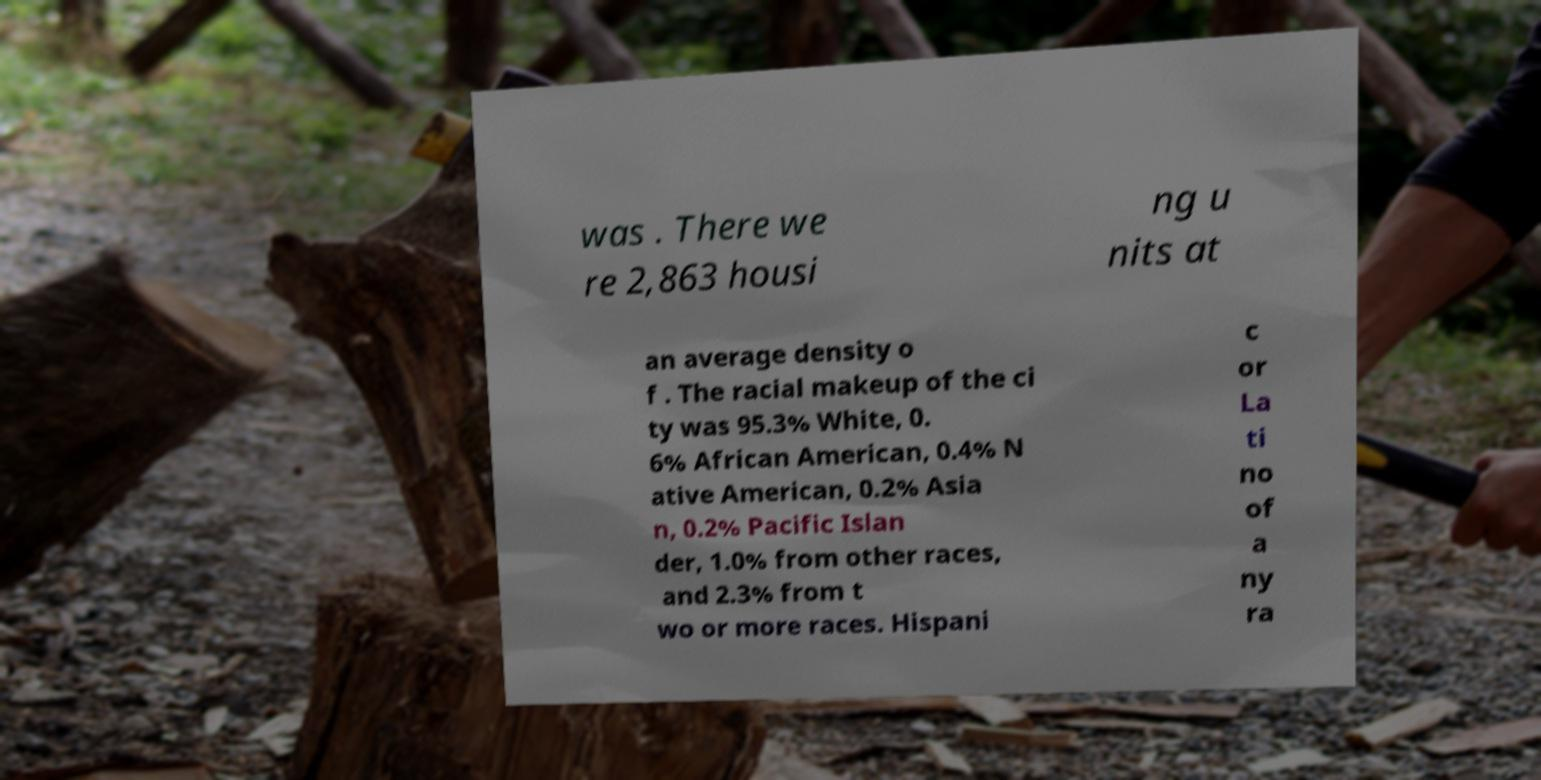Can you read and provide the text displayed in the image?This photo seems to have some interesting text. Can you extract and type it out for me? was . There we re 2,863 housi ng u nits at an average density o f . The racial makeup of the ci ty was 95.3% White, 0. 6% African American, 0.4% N ative American, 0.2% Asia n, 0.2% Pacific Islan der, 1.0% from other races, and 2.3% from t wo or more races. Hispani c or La ti no of a ny ra 